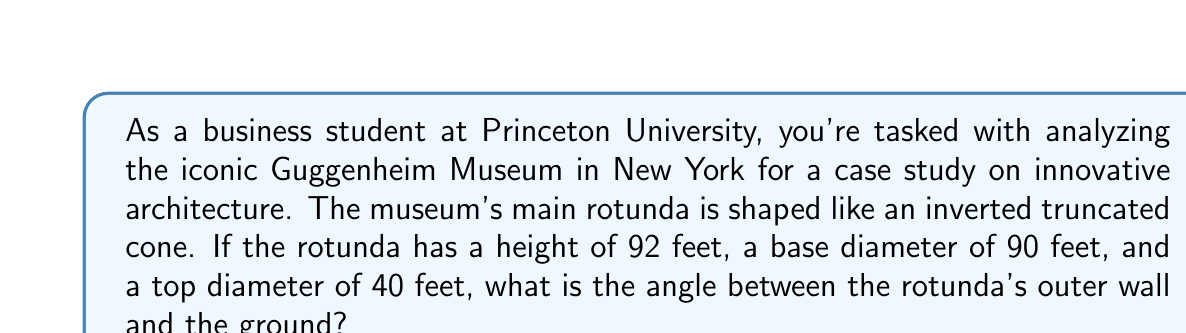Teach me how to tackle this problem. To solve this problem, we'll follow these steps:

1) First, we need to visualize the problem. The rotunda forms a truncated cone, and we're looking for the angle between its outer wall and the ground.

2) We can find this angle by considering a right triangle formed by:
   - The vertical height of the rotunda
   - Half the difference between the base and top radii
   - The slant height of the rotunda's wall

3) Let's define our variables:
   $h$ = height = 92 feet
   $r_1$ = base radius = 90/2 = 45 feet
   $r_2$ = top radius = 40/2 = 20 feet

4) The difference in radii is:
   $\Delta r = r_1 - r_2 = 45 - 20 = 25$ feet

5) Now we can use the arctangent function to find the angle. If we call our angle $\theta$:

   $$\tan(\theta) = \frac{h}{\Delta r} = \frac{92}{25}$$

6) Therefore:

   $$\theta = \arctan(\frac{92}{25})$$

7) Using a calculator or computer:

   $$\theta \approx 74.82^\circ$$

8) This angle is measured from the vertical. To get the angle from the ground, we subtract from 90°:

   $$90^\circ - 74.82^\circ = 15.18^\circ$$

[asy]
import geometry;

size(200);

pair A = (0,0), B = (25,0), C = (0,92);
draw(A--B--C--A);
draw(A--(0,100),dashed);

label("92'", (0,46), W);
label("25'", (12.5,0), S);
label("θ", (2,5), NW);

draw(arc(A,3,90,74.82),Arrow);
[/asy]
Answer: $15.18^\circ$ 